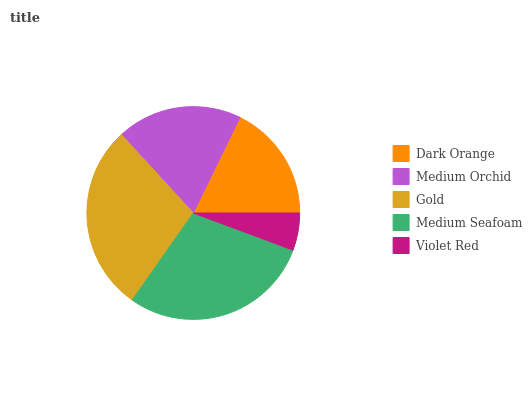Is Violet Red the minimum?
Answer yes or no. Yes. Is Medium Seafoam the maximum?
Answer yes or no. Yes. Is Medium Orchid the minimum?
Answer yes or no. No. Is Medium Orchid the maximum?
Answer yes or no. No. Is Medium Orchid greater than Dark Orange?
Answer yes or no. Yes. Is Dark Orange less than Medium Orchid?
Answer yes or no. Yes. Is Dark Orange greater than Medium Orchid?
Answer yes or no. No. Is Medium Orchid less than Dark Orange?
Answer yes or no. No. Is Medium Orchid the high median?
Answer yes or no. Yes. Is Medium Orchid the low median?
Answer yes or no. Yes. Is Violet Red the high median?
Answer yes or no. No. Is Violet Red the low median?
Answer yes or no. No. 